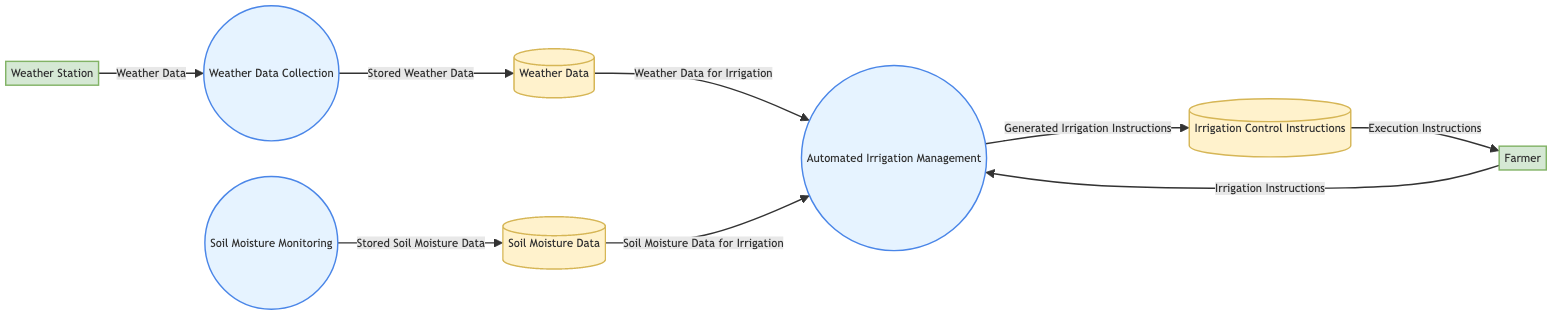What is the name of the process that manages irrigation? The diagram identifies "Automated Irrigation Management" as the primary process dedicated to managing irrigation tasks.
Answer: Automated Irrigation Management How many data stores are present in the diagram? On analyzing the diagram, there are three distinct data stores labeled "Soil Moisture Data," "Weather Data," and "Irrigation Control Instructions."
Answer: 3 Which external entity provides weather data to the system? The diagram shows that the "Weather Station" is the external entity responsible for supplying weather data to the process of "Weather Data Collection."
Answer: Weather Station What data flows from the soil moisture monitoring process to a data store? The diagram indicates that the "Soil Moisture Monitoring" process transfers "Stored Soil Moisture Data" to the data store named "Soil Moisture Data."
Answer: Stored Soil Moisture Data What type of instructions does the farmer send to the automated irrigation management process? According to the diagram, the farmer sends "Irrigation Instructions" to the "Automated Irrigation Management" process which are essential for its operation.
Answer: Irrigation Instructions How does weather data get stored after collection? The flow indicates that after collection, the "Weather Data" received from the "Weather Station" is sent to the data store termed "Weather Data" as "Stored Weather Data."
Answer: Stored Weather Data What does the irrigation management process produce as an output to a data store? The output generated by the "Automated Irrigation Management" process is referred to as "Generated Irrigation Instructions," which are stored in the data store called "Irrigation Control Instructions."
Answer: Generated Irrigation Instructions What is the final flow segment directed to the farmer? The diagram specifies that the "Execution Instructions" are directed from the data store "Irrigation Control Instructions" to the external entity "Farmer."
Answer: Execution Instructions Which process receives soil moisture data for irrigation? The diagram indicates that the "Automated Irrigation Management" process receives "Soil Moisture Data for Irrigation" from the data store "Soil Moisture Data."
Answer: Automated Irrigation Management 